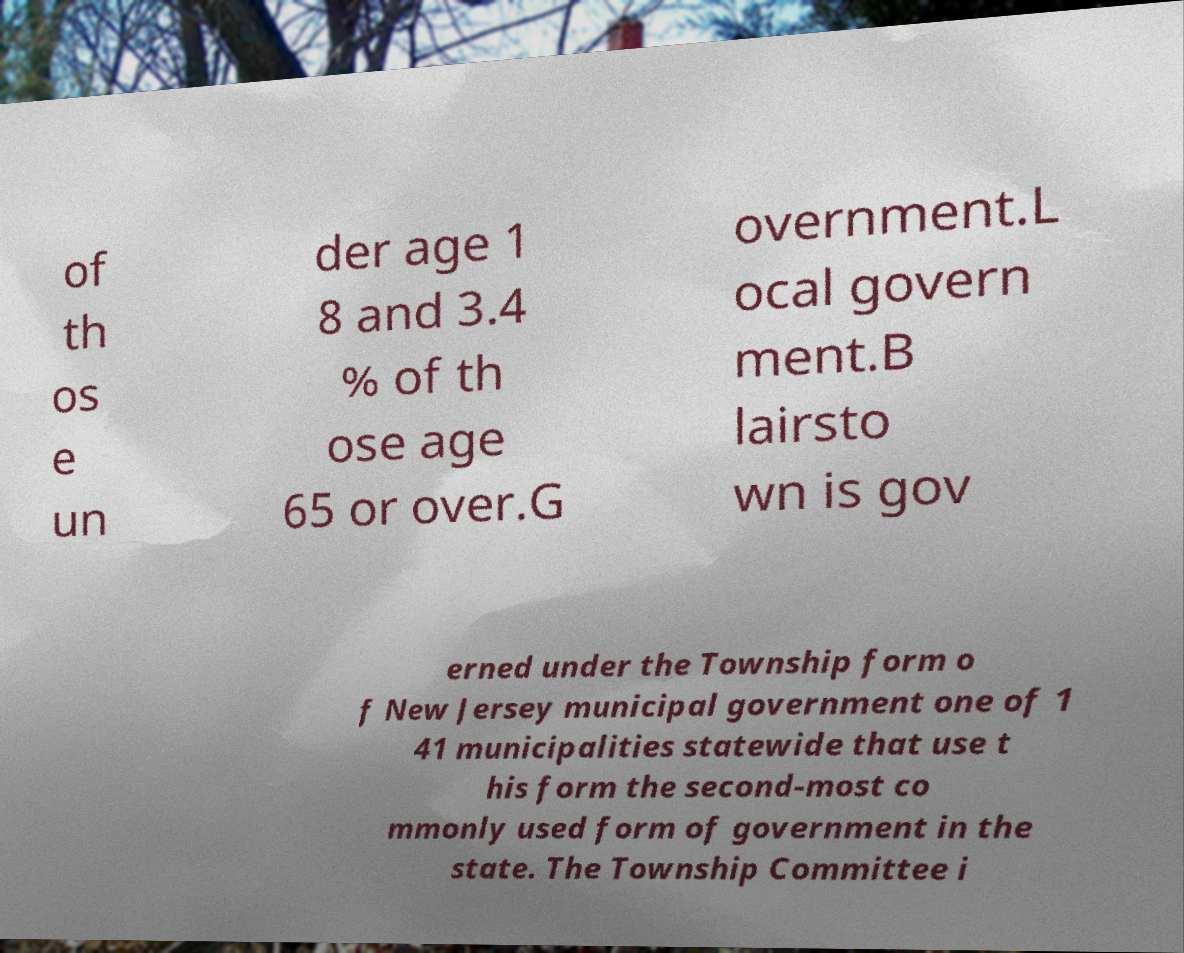For documentation purposes, I need the text within this image transcribed. Could you provide that? of th os e un der age 1 8 and 3.4 % of th ose age 65 or over.G overnment.L ocal govern ment.B lairsto wn is gov erned under the Township form o f New Jersey municipal government one of 1 41 municipalities statewide that use t his form the second-most co mmonly used form of government in the state. The Township Committee i 